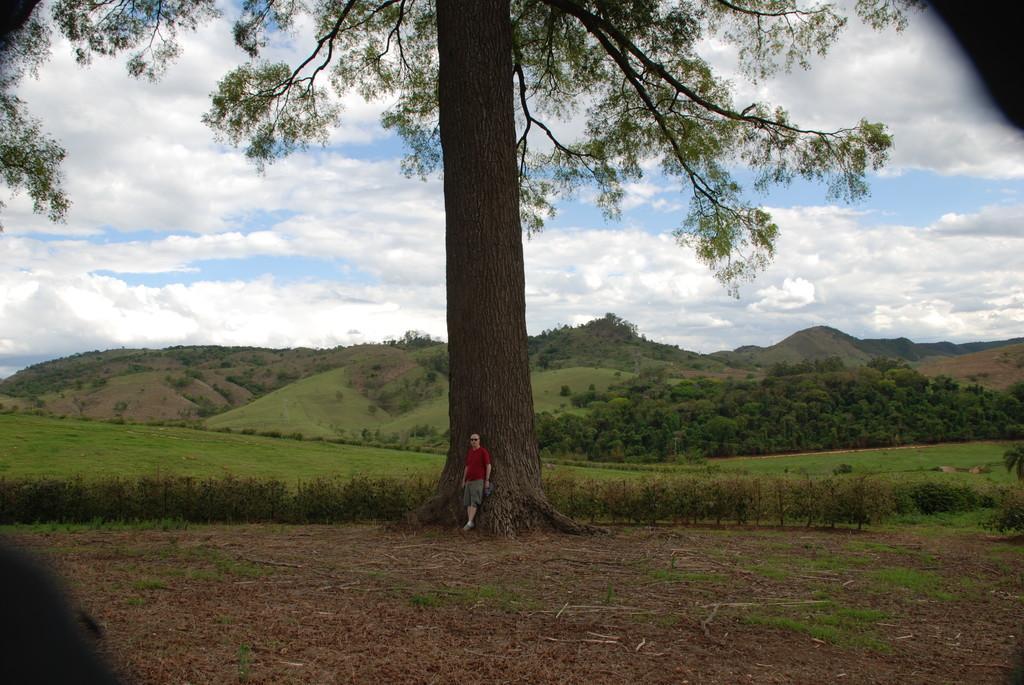Please provide a concise description of this image. In this image we can see a person, there are trees, plants, grass, mountains, also we can see the cloudy sky. 